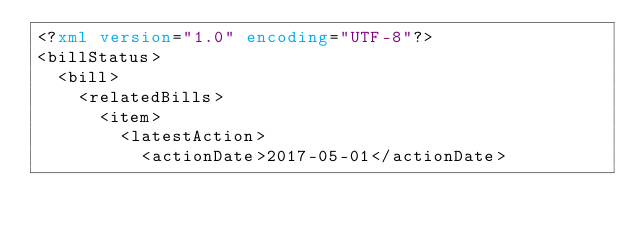Convert code to text. <code><loc_0><loc_0><loc_500><loc_500><_XML_><?xml version="1.0" encoding="UTF-8"?>
<billStatus>
  <bill>
    <relatedBills>
      <item>
        <latestAction>
          <actionDate>2017-05-01</actionDate></code> 